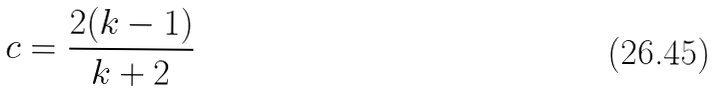<formula> <loc_0><loc_0><loc_500><loc_500>c = \frac { 2 ( k - 1 ) } { k + 2 }</formula> 